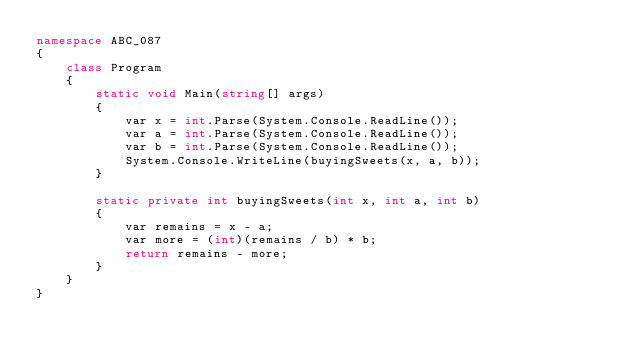<code> <loc_0><loc_0><loc_500><loc_500><_C#_>namespace ABC_087
{
    class Program
    {
        static void Main(string[] args)
        {
            var x = int.Parse(System.Console.ReadLine());
            var a = int.Parse(System.Console.ReadLine());
            var b = int.Parse(System.Console.ReadLine());
            System.Console.WriteLine(buyingSweets(x, a, b));
        }

        static private int buyingSweets(int x, int a, int b)
        {
            var remains = x - a;
            var more = (int)(remains / b) * b;
            return remains - more;
        }
    }
}
</code> 